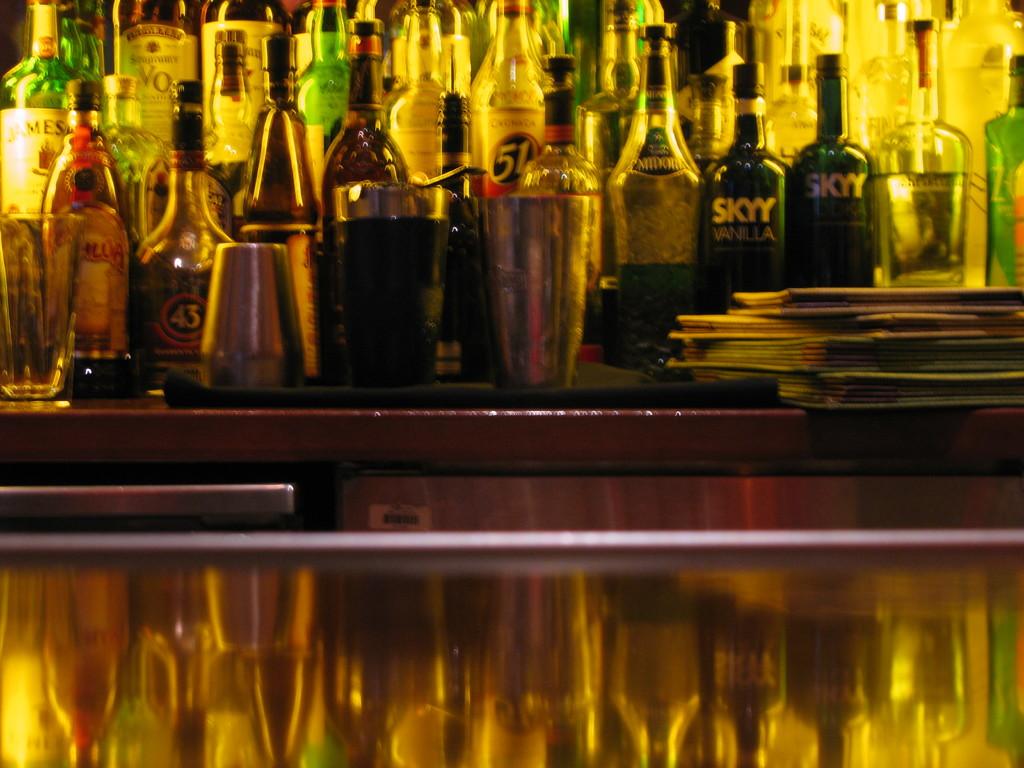Is skyy back there?
Your answer should be very brief. Yes. 